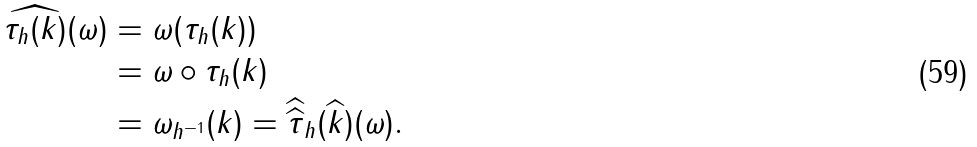Convert formula to latex. <formula><loc_0><loc_0><loc_500><loc_500>\widehat { \tau _ { h } ( k ) } ( \omega ) & = \omega ( \tau _ { h } ( k ) ) \\ & = \omega \circ \tau _ { h } ( k ) \\ & = \omega _ { h ^ { - 1 } } ( k ) = \widehat { \widehat { \tau } } _ { h } ( \widehat { k } ) ( \omega ) .</formula> 